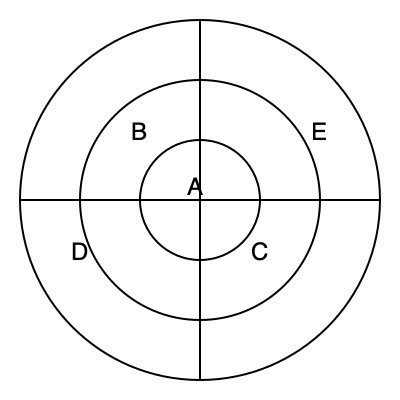In the cellular network diagram above, which area represents the region where a mobile device would need to perform a handoff between different cell towers to maintain continuous service? To answer this question, we need to understand the structure of a cellular network and the concept of handoffs:

1. The diagram shows a cellular network with concentric circles representing different coverage areas.

2. Each circle represents the boundary of a cell, which is the area covered by a single cell tower.

3. The innermost circle (A) represents the strongest signal area, typically closest to the cell tower.

4. The outer circles (B, C, D, E) represent areas with progressively weaker signals as you move away from the center.

5. Handoffs occur when a mobile device moves from one cell to another, requiring a transfer of service between cell towers.

6. This transfer typically happens at the boundary between cells, where the signal from one tower becomes weaker than the signal from a neighboring tower.

7. In the diagram, the areas between the concentric circles represent these boundary regions where handoffs would occur.

8. Specifically, the area between the middle circle and the outermost circle (containing regions B, C, D, and E) is where handoffs are most likely to happen as a device moves between different cell towers' coverage areas.

Therefore, the region where a mobile device would need to perform a handoff is the area between the middle and outermost circles, which includes regions B, C, D, and E.
Answer: The area between the middle and outermost circles (regions B, C, D, and E). 